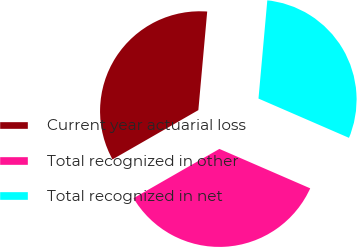Convert chart to OTSL. <chart><loc_0><loc_0><loc_500><loc_500><pie_chart><fcel>Current year actuarial loss<fcel>Total recognized in other<fcel>Total recognized in net<nl><fcel>34.72%<fcel>35.19%<fcel>30.09%<nl></chart> 